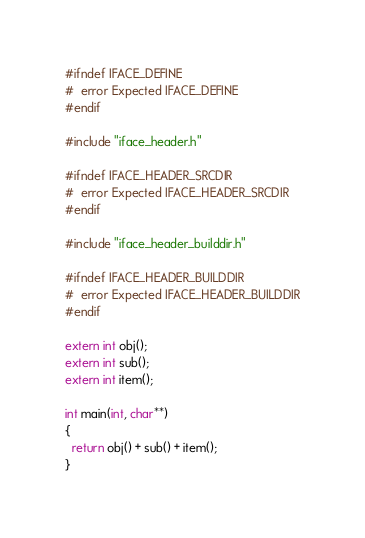<code> <loc_0><loc_0><loc_500><loc_500><_C++_>
#ifndef IFACE_DEFINE
#  error Expected IFACE_DEFINE
#endif

#include "iface_header.h"

#ifndef IFACE_HEADER_SRCDIR
#  error Expected IFACE_HEADER_SRCDIR
#endif

#include "iface_header_builddir.h"

#ifndef IFACE_HEADER_BUILDDIR
#  error Expected IFACE_HEADER_BUILDDIR
#endif

extern int obj();
extern int sub();
extern int item();

int main(int, char**)
{
  return obj() + sub() + item();
}
</code> 